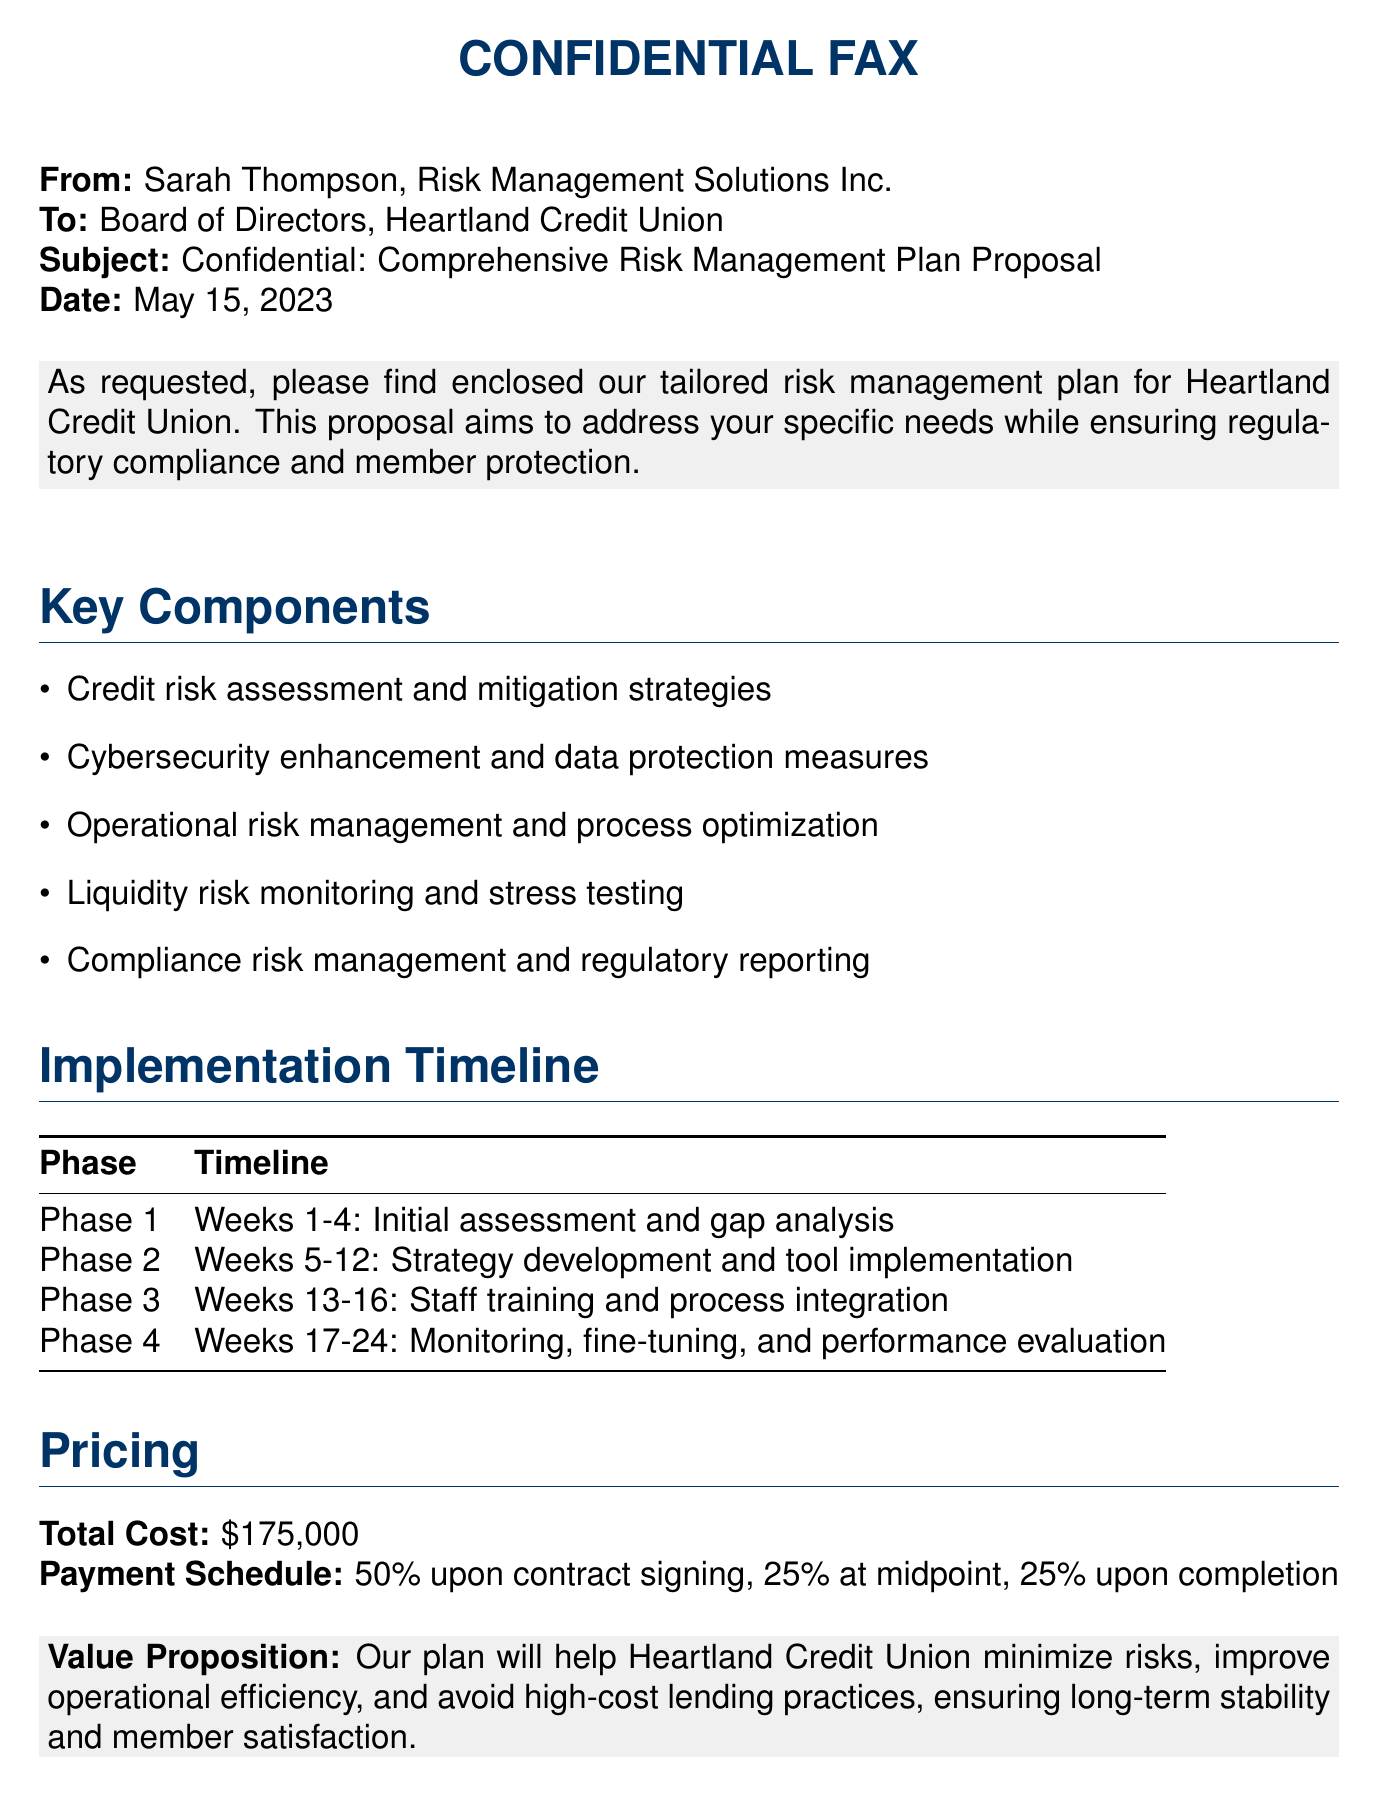What is the total cost of the proposal? The total cost is clearly stated in the pricing section of the document.
Answer: $175,000 What is the payment schedule? The payment schedule is outlined in the pricing section, detailing the payment percentages at different stages.
Answer: 50% upon contract signing, 25% at midpoint, 25% upon completion How long will the first phase take? The timeline for Phase 1 is specified in the implementation timeline table.
Answer: Weeks 1-4 Who is the sender of the fax? The sender's name and organization are mentioned at the beginning of the document.
Answer: Sarah Thompson, Risk Management Solutions Inc What is one of the key components of the risk management plan? Key components are listed in the document, providing specific areas of focus in the proposal.
Answer: Cybersecurity enhancement and data protection measures What is the final phase of the implementation timeline? The final phase is the last entry in the provided implementation timeline section.
Answer: Phase 4: Weeks 17-24 What is the purpose of the value proposition? The value proposition is explained at the end of the proposal, highlighting the benefits of the plan.
Answer: Help Heartland Credit Union minimize risks, improve operational efficiency, and avoid high-cost lending practices In what document is the proposal's date mentioned? The date of the document is provided in the header section of the communication.
Answer: May 15, 2023 